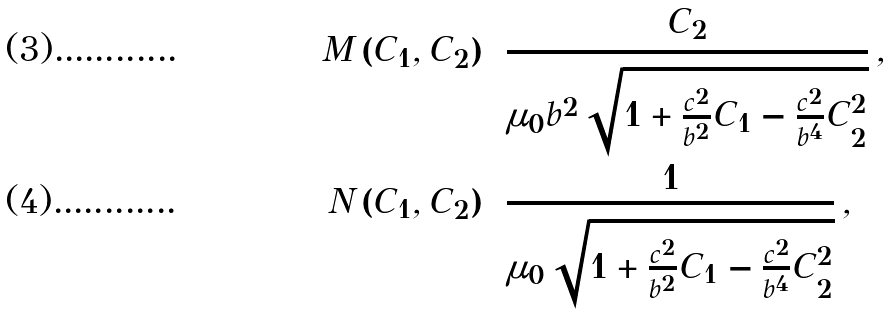Convert formula to latex. <formula><loc_0><loc_0><loc_500><loc_500>M \left ( C _ { 1 } , C _ { 2 } \right ) & = \frac { C _ { 2 } } { \mu _ { 0 } b ^ { 2 } \sqrt { 1 + \frac { c ^ { 2 } } { b ^ { 2 } } C _ { 1 } - \frac { c ^ { 2 } } { b ^ { 4 } } C _ { 2 } ^ { 2 } } } \, , \\ N \left ( C _ { 1 } , C _ { 2 } \right ) & = \frac { 1 } { \mu _ { 0 } \sqrt { 1 + \frac { c ^ { 2 } } { b ^ { 2 } } C _ { 1 } - \frac { c ^ { 2 } } { b ^ { 4 } } C _ { 2 } ^ { 2 } } } \, ,</formula> 